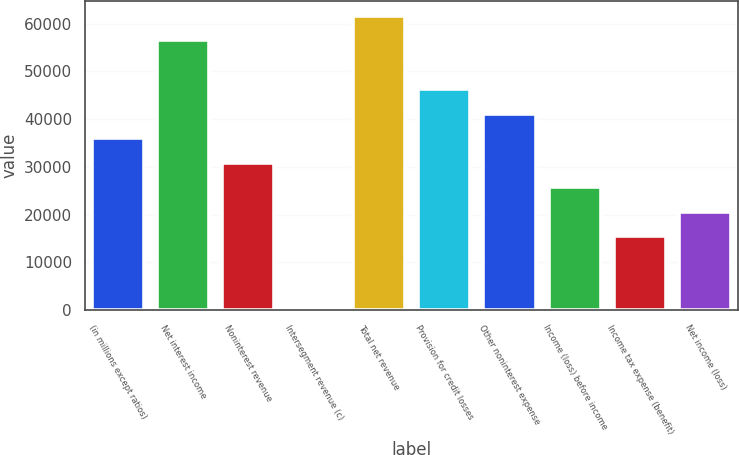<chart> <loc_0><loc_0><loc_500><loc_500><bar_chart><fcel>(in millions except ratios)<fcel>Net interest income<fcel>Noninterest revenue<fcel>Intersegment revenue (c)<fcel>Total net revenue<fcel>Provision for credit losses<fcel>Other noninterest expense<fcel>Income (loss) before income<fcel>Income tax expense (benefit)<fcel>Net income (loss)<nl><fcel>35985.7<fcel>56546.1<fcel>30845.6<fcel>5<fcel>61686.2<fcel>46265.9<fcel>41125.8<fcel>25705.5<fcel>15425.3<fcel>20565.4<nl></chart> 